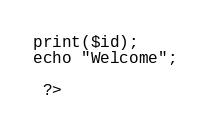<code> <loc_0><loc_0><loc_500><loc_500><_PHP_>print($id);
echo "Welcome";

 ?>
</code> 